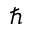Convert formula to latex. <formula><loc_0><loc_0><loc_500><loc_500>\hbar</formula> 